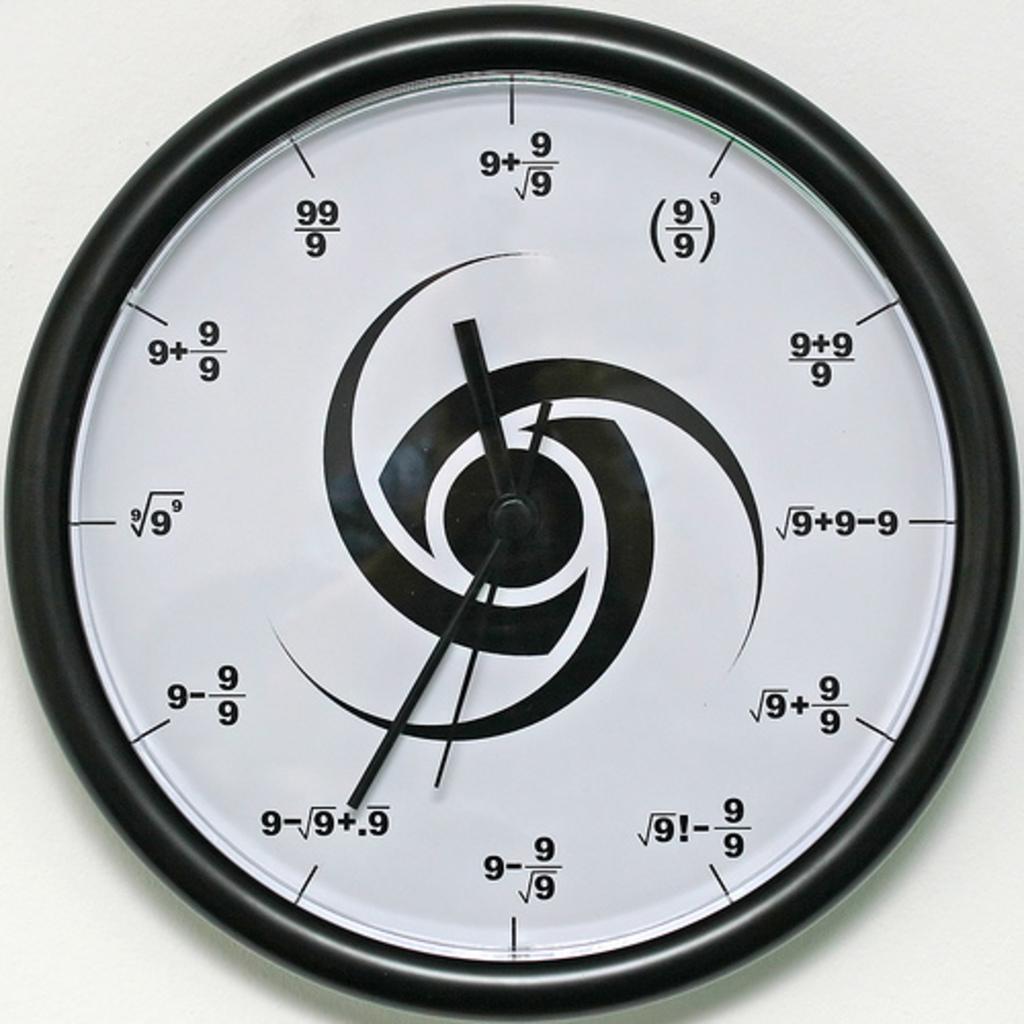Can you describe this image briefly? In this picture I can see a wall clock and I can see white color background. 